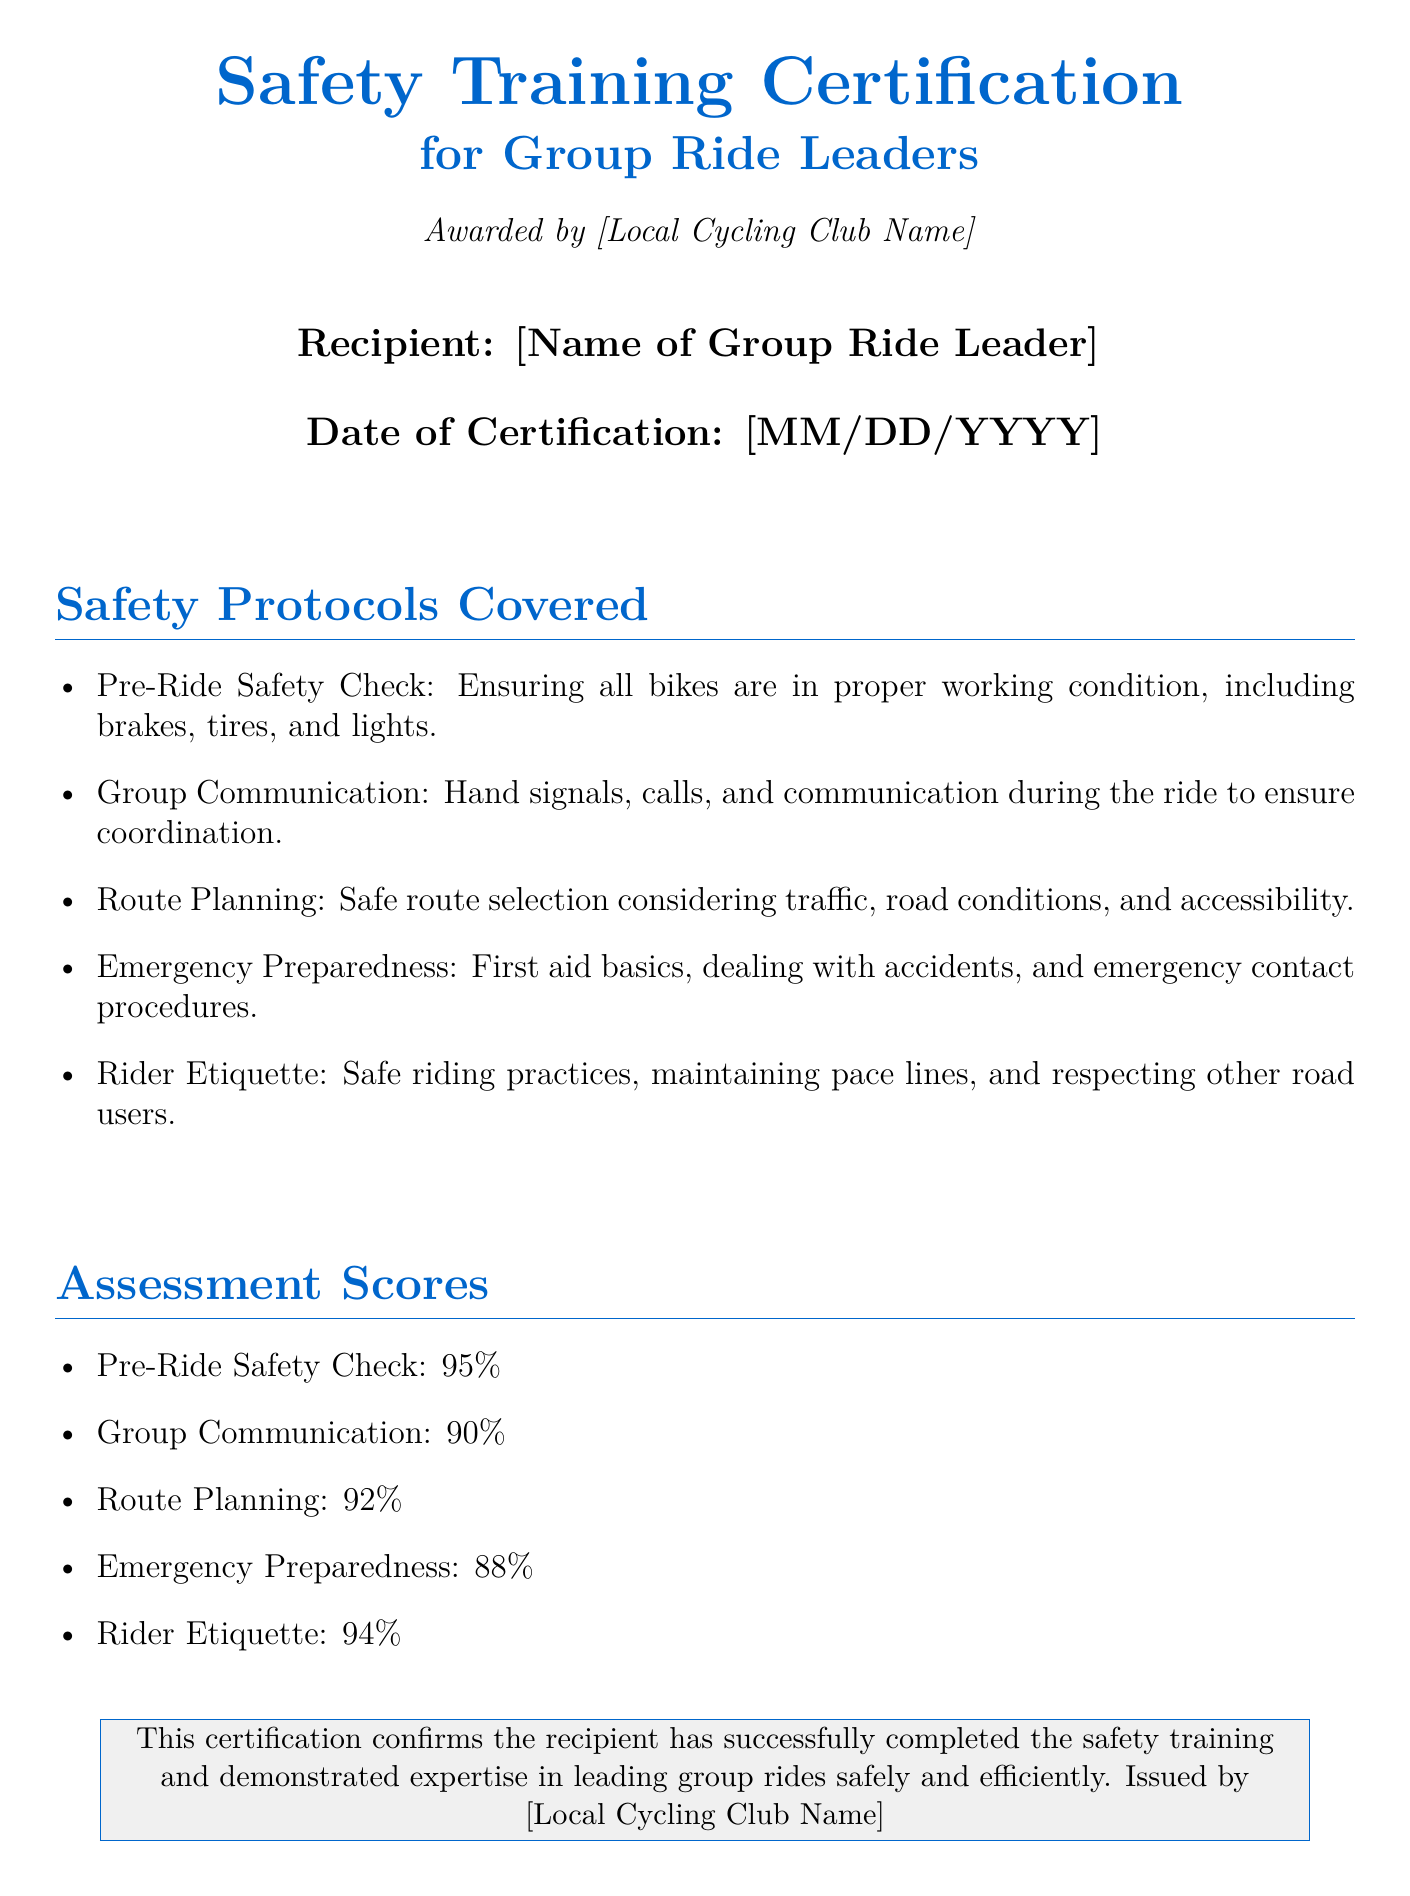What is the title of the certification? The title is found prominently at the beginning of the document, indicating the type of training completed.
Answer: Safety Training Certification Who is the recipient of the certification? The recipient's name is specified in the section dedicated to the award details.
Answer: [Name of Group Ride Leader] What is the date of certification? The certification date is stated in the related section of the document.
Answer: [MM/DD/YYYY] What percentage did the recipient score in Emergency Preparedness? The percentage for each assessment category, including Emergency Preparedness, is listed in the document.
Answer: 88% What safety protocol involves bike maintenance? The protocols listed provide specific tasks that contribute to safety during rides.
Answer: Pre-Ride Safety Check Which safety protocol discusses communication? The protocols mentioned cover various aspects of leading a safe group ride, including communication methods.
Answer: Group Communication What is the average score of the assessment categories? The average score can be computed from the individual scores listed for each assessment category.
Answer: 91% What organization awarded the certification? The sponsoring organization is indicated at the top of the document, showing an endorsement of the recipient's training.
Answer: [Local Cycling Club Name] 